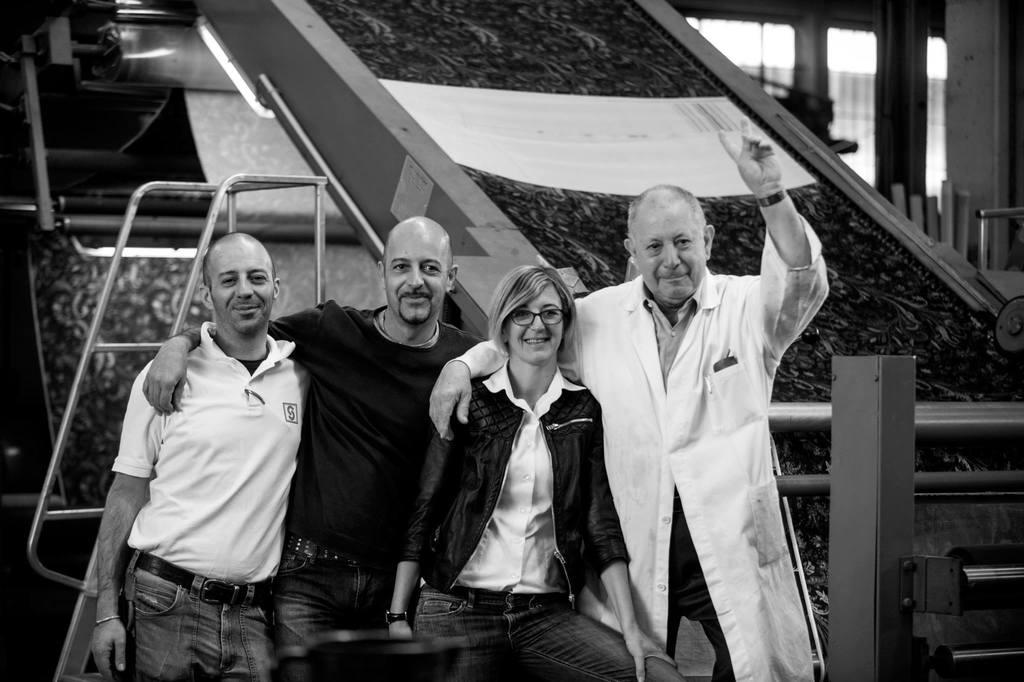How many persons are in the image? There are persons in the image. What can be observed about the attire of the persons? The persons are wearing different color dresses. What is the facial expression of the persons? The persons are smiling. What position are the persons in? The persons are standing. What else can be seen in the image besides the persons? There are other objects in the background of the image. What type of spring is visible in the image? There is no spring present in the image. What is the reason for the persons to be standing in the image? The image does not provide any information about the reason for the persons to be standing. 